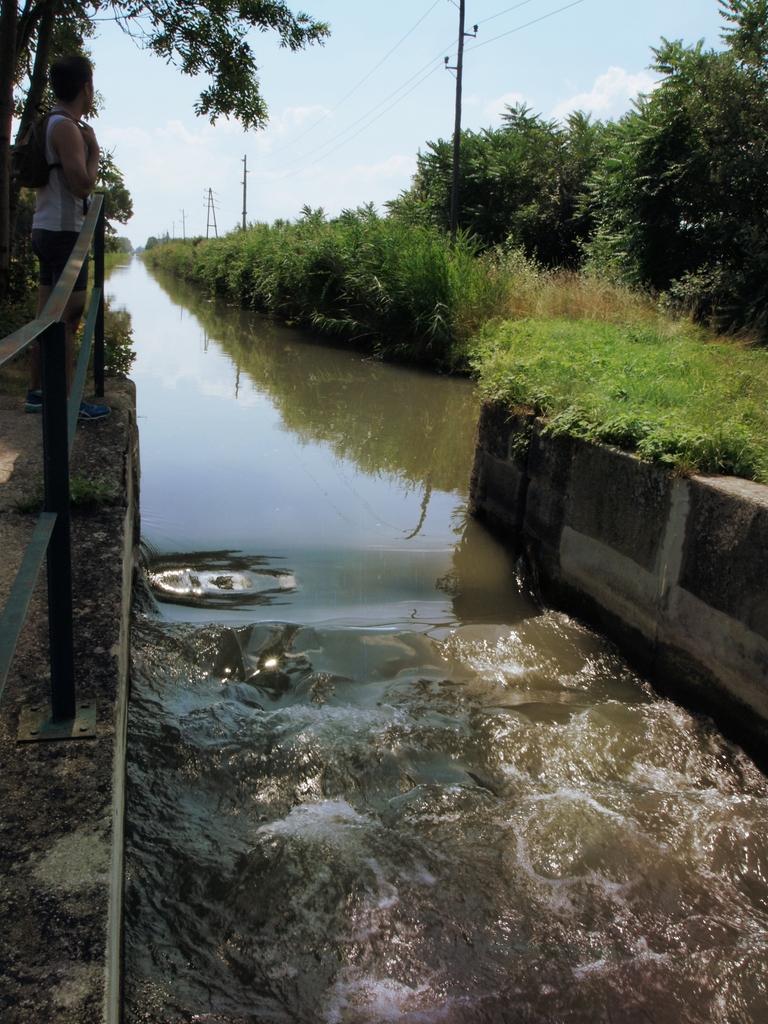How would you summarize this image in a sentence or two? In this image we can see sky with clouds, trees, electric poles, electric cables, person standing on the bridge and running water. 